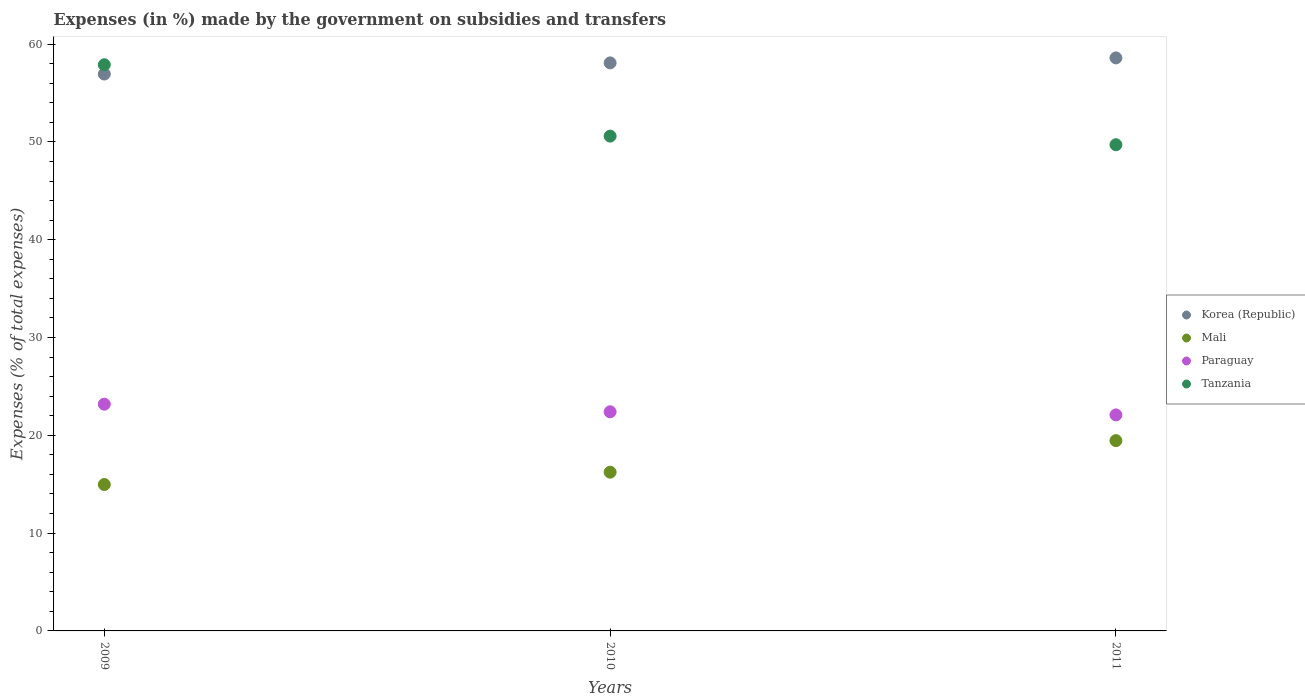How many different coloured dotlines are there?
Ensure brevity in your answer.  4. What is the percentage of expenses made by the government on subsidies and transfers in Tanzania in 2011?
Offer a very short reply. 49.71. Across all years, what is the maximum percentage of expenses made by the government on subsidies and transfers in Mali?
Your response must be concise. 19.46. Across all years, what is the minimum percentage of expenses made by the government on subsidies and transfers in Korea (Republic)?
Provide a succinct answer. 56.94. In which year was the percentage of expenses made by the government on subsidies and transfers in Tanzania maximum?
Your answer should be very brief. 2009. What is the total percentage of expenses made by the government on subsidies and transfers in Mali in the graph?
Offer a very short reply. 50.65. What is the difference between the percentage of expenses made by the government on subsidies and transfers in Paraguay in 2009 and that in 2010?
Make the answer very short. 0.78. What is the difference between the percentage of expenses made by the government on subsidies and transfers in Paraguay in 2011 and the percentage of expenses made by the government on subsidies and transfers in Korea (Republic) in 2009?
Your response must be concise. -34.85. What is the average percentage of expenses made by the government on subsidies and transfers in Korea (Republic) per year?
Your response must be concise. 57.87. In the year 2010, what is the difference between the percentage of expenses made by the government on subsidies and transfers in Paraguay and percentage of expenses made by the government on subsidies and transfers in Tanzania?
Provide a succinct answer. -28.19. What is the ratio of the percentage of expenses made by the government on subsidies and transfers in Paraguay in 2010 to that in 2011?
Keep it short and to the point. 1.01. Is the percentage of expenses made by the government on subsidies and transfers in Paraguay in 2009 less than that in 2010?
Make the answer very short. No. What is the difference between the highest and the second highest percentage of expenses made by the government on subsidies and transfers in Tanzania?
Make the answer very short. 7.3. What is the difference between the highest and the lowest percentage of expenses made by the government on subsidies and transfers in Korea (Republic)?
Give a very brief answer. 1.65. Does the percentage of expenses made by the government on subsidies and transfers in Mali monotonically increase over the years?
Offer a very short reply. Yes. Is the percentage of expenses made by the government on subsidies and transfers in Mali strictly less than the percentage of expenses made by the government on subsidies and transfers in Paraguay over the years?
Give a very brief answer. Yes. How many years are there in the graph?
Keep it short and to the point. 3. What is the difference between two consecutive major ticks on the Y-axis?
Make the answer very short. 10. Are the values on the major ticks of Y-axis written in scientific E-notation?
Your answer should be compact. No. How many legend labels are there?
Provide a succinct answer. 4. What is the title of the graph?
Ensure brevity in your answer.  Expenses (in %) made by the government on subsidies and transfers. What is the label or title of the Y-axis?
Provide a short and direct response. Expenses (% of total expenses). What is the Expenses (% of total expenses) in Korea (Republic) in 2009?
Provide a succinct answer. 56.94. What is the Expenses (% of total expenses) in Mali in 2009?
Your answer should be compact. 14.97. What is the Expenses (% of total expenses) of Paraguay in 2009?
Keep it short and to the point. 23.18. What is the Expenses (% of total expenses) of Tanzania in 2009?
Your answer should be compact. 57.89. What is the Expenses (% of total expenses) in Korea (Republic) in 2010?
Give a very brief answer. 58.08. What is the Expenses (% of total expenses) in Mali in 2010?
Your response must be concise. 16.23. What is the Expenses (% of total expenses) of Paraguay in 2010?
Make the answer very short. 22.4. What is the Expenses (% of total expenses) in Tanzania in 2010?
Your answer should be very brief. 50.59. What is the Expenses (% of total expenses) in Korea (Republic) in 2011?
Your answer should be very brief. 58.59. What is the Expenses (% of total expenses) of Mali in 2011?
Offer a very short reply. 19.46. What is the Expenses (% of total expenses) in Paraguay in 2011?
Your answer should be very brief. 22.09. What is the Expenses (% of total expenses) in Tanzania in 2011?
Provide a succinct answer. 49.71. Across all years, what is the maximum Expenses (% of total expenses) in Korea (Republic)?
Give a very brief answer. 58.59. Across all years, what is the maximum Expenses (% of total expenses) in Mali?
Your answer should be very brief. 19.46. Across all years, what is the maximum Expenses (% of total expenses) of Paraguay?
Provide a succinct answer. 23.18. Across all years, what is the maximum Expenses (% of total expenses) in Tanzania?
Offer a very short reply. 57.89. Across all years, what is the minimum Expenses (% of total expenses) in Korea (Republic)?
Make the answer very short. 56.94. Across all years, what is the minimum Expenses (% of total expenses) of Mali?
Offer a terse response. 14.97. Across all years, what is the minimum Expenses (% of total expenses) in Paraguay?
Offer a very short reply. 22.09. Across all years, what is the minimum Expenses (% of total expenses) of Tanzania?
Provide a short and direct response. 49.71. What is the total Expenses (% of total expenses) of Korea (Republic) in the graph?
Make the answer very short. 173.6. What is the total Expenses (% of total expenses) in Mali in the graph?
Make the answer very short. 50.65. What is the total Expenses (% of total expenses) of Paraguay in the graph?
Give a very brief answer. 67.67. What is the total Expenses (% of total expenses) in Tanzania in the graph?
Give a very brief answer. 158.19. What is the difference between the Expenses (% of total expenses) of Korea (Republic) in 2009 and that in 2010?
Provide a succinct answer. -1.14. What is the difference between the Expenses (% of total expenses) in Mali in 2009 and that in 2010?
Keep it short and to the point. -1.26. What is the difference between the Expenses (% of total expenses) in Paraguay in 2009 and that in 2010?
Make the answer very short. 0.78. What is the difference between the Expenses (% of total expenses) in Tanzania in 2009 and that in 2010?
Provide a succinct answer. 7.3. What is the difference between the Expenses (% of total expenses) of Korea (Republic) in 2009 and that in 2011?
Your answer should be very brief. -1.65. What is the difference between the Expenses (% of total expenses) in Mali in 2009 and that in 2011?
Make the answer very short. -4.49. What is the difference between the Expenses (% of total expenses) of Paraguay in 2009 and that in 2011?
Provide a succinct answer. 1.1. What is the difference between the Expenses (% of total expenses) of Tanzania in 2009 and that in 2011?
Offer a terse response. 8.18. What is the difference between the Expenses (% of total expenses) of Korea (Republic) in 2010 and that in 2011?
Your answer should be very brief. -0.51. What is the difference between the Expenses (% of total expenses) in Mali in 2010 and that in 2011?
Provide a succinct answer. -3.23. What is the difference between the Expenses (% of total expenses) of Paraguay in 2010 and that in 2011?
Ensure brevity in your answer.  0.32. What is the difference between the Expenses (% of total expenses) in Tanzania in 2010 and that in 2011?
Keep it short and to the point. 0.88. What is the difference between the Expenses (% of total expenses) in Korea (Republic) in 2009 and the Expenses (% of total expenses) in Mali in 2010?
Offer a very short reply. 40.71. What is the difference between the Expenses (% of total expenses) in Korea (Republic) in 2009 and the Expenses (% of total expenses) in Paraguay in 2010?
Offer a terse response. 34.53. What is the difference between the Expenses (% of total expenses) in Korea (Republic) in 2009 and the Expenses (% of total expenses) in Tanzania in 2010?
Offer a very short reply. 6.35. What is the difference between the Expenses (% of total expenses) in Mali in 2009 and the Expenses (% of total expenses) in Paraguay in 2010?
Ensure brevity in your answer.  -7.44. What is the difference between the Expenses (% of total expenses) in Mali in 2009 and the Expenses (% of total expenses) in Tanzania in 2010?
Give a very brief answer. -35.62. What is the difference between the Expenses (% of total expenses) of Paraguay in 2009 and the Expenses (% of total expenses) of Tanzania in 2010?
Offer a very short reply. -27.41. What is the difference between the Expenses (% of total expenses) in Korea (Republic) in 2009 and the Expenses (% of total expenses) in Mali in 2011?
Ensure brevity in your answer.  37.48. What is the difference between the Expenses (% of total expenses) of Korea (Republic) in 2009 and the Expenses (% of total expenses) of Paraguay in 2011?
Your answer should be very brief. 34.85. What is the difference between the Expenses (% of total expenses) of Korea (Republic) in 2009 and the Expenses (% of total expenses) of Tanzania in 2011?
Provide a succinct answer. 7.23. What is the difference between the Expenses (% of total expenses) of Mali in 2009 and the Expenses (% of total expenses) of Paraguay in 2011?
Offer a terse response. -7.12. What is the difference between the Expenses (% of total expenses) of Mali in 2009 and the Expenses (% of total expenses) of Tanzania in 2011?
Your response must be concise. -34.74. What is the difference between the Expenses (% of total expenses) in Paraguay in 2009 and the Expenses (% of total expenses) in Tanzania in 2011?
Your response must be concise. -26.53. What is the difference between the Expenses (% of total expenses) in Korea (Republic) in 2010 and the Expenses (% of total expenses) in Mali in 2011?
Offer a very short reply. 38.62. What is the difference between the Expenses (% of total expenses) of Korea (Republic) in 2010 and the Expenses (% of total expenses) of Paraguay in 2011?
Your answer should be very brief. 35.99. What is the difference between the Expenses (% of total expenses) of Korea (Republic) in 2010 and the Expenses (% of total expenses) of Tanzania in 2011?
Offer a very short reply. 8.37. What is the difference between the Expenses (% of total expenses) in Mali in 2010 and the Expenses (% of total expenses) in Paraguay in 2011?
Make the answer very short. -5.86. What is the difference between the Expenses (% of total expenses) of Mali in 2010 and the Expenses (% of total expenses) of Tanzania in 2011?
Offer a terse response. -33.48. What is the difference between the Expenses (% of total expenses) in Paraguay in 2010 and the Expenses (% of total expenses) in Tanzania in 2011?
Keep it short and to the point. -27.31. What is the average Expenses (% of total expenses) in Korea (Republic) per year?
Make the answer very short. 57.87. What is the average Expenses (% of total expenses) in Mali per year?
Make the answer very short. 16.88. What is the average Expenses (% of total expenses) of Paraguay per year?
Ensure brevity in your answer.  22.56. What is the average Expenses (% of total expenses) of Tanzania per year?
Make the answer very short. 52.73. In the year 2009, what is the difference between the Expenses (% of total expenses) in Korea (Republic) and Expenses (% of total expenses) in Mali?
Keep it short and to the point. 41.97. In the year 2009, what is the difference between the Expenses (% of total expenses) in Korea (Republic) and Expenses (% of total expenses) in Paraguay?
Offer a terse response. 33.76. In the year 2009, what is the difference between the Expenses (% of total expenses) in Korea (Republic) and Expenses (% of total expenses) in Tanzania?
Keep it short and to the point. -0.95. In the year 2009, what is the difference between the Expenses (% of total expenses) in Mali and Expenses (% of total expenses) in Paraguay?
Your answer should be compact. -8.21. In the year 2009, what is the difference between the Expenses (% of total expenses) of Mali and Expenses (% of total expenses) of Tanzania?
Offer a very short reply. -42.92. In the year 2009, what is the difference between the Expenses (% of total expenses) of Paraguay and Expenses (% of total expenses) of Tanzania?
Keep it short and to the point. -34.71. In the year 2010, what is the difference between the Expenses (% of total expenses) of Korea (Republic) and Expenses (% of total expenses) of Mali?
Your answer should be compact. 41.85. In the year 2010, what is the difference between the Expenses (% of total expenses) of Korea (Republic) and Expenses (% of total expenses) of Paraguay?
Provide a short and direct response. 35.67. In the year 2010, what is the difference between the Expenses (% of total expenses) in Korea (Republic) and Expenses (% of total expenses) in Tanzania?
Make the answer very short. 7.49. In the year 2010, what is the difference between the Expenses (% of total expenses) of Mali and Expenses (% of total expenses) of Paraguay?
Provide a short and direct response. -6.18. In the year 2010, what is the difference between the Expenses (% of total expenses) of Mali and Expenses (% of total expenses) of Tanzania?
Offer a very short reply. -34.36. In the year 2010, what is the difference between the Expenses (% of total expenses) in Paraguay and Expenses (% of total expenses) in Tanzania?
Give a very brief answer. -28.19. In the year 2011, what is the difference between the Expenses (% of total expenses) in Korea (Republic) and Expenses (% of total expenses) in Mali?
Your answer should be very brief. 39.13. In the year 2011, what is the difference between the Expenses (% of total expenses) in Korea (Republic) and Expenses (% of total expenses) in Paraguay?
Give a very brief answer. 36.5. In the year 2011, what is the difference between the Expenses (% of total expenses) of Korea (Republic) and Expenses (% of total expenses) of Tanzania?
Ensure brevity in your answer.  8.88. In the year 2011, what is the difference between the Expenses (% of total expenses) of Mali and Expenses (% of total expenses) of Paraguay?
Your response must be concise. -2.63. In the year 2011, what is the difference between the Expenses (% of total expenses) in Mali and Expenses (% of total expenses) in Tanzania?
Ensure brevity in your answer.  -30.25. In the year 2011, what is the difference between the Expenses (% of total expenses) of Paraguay and Expenses (% of total expenses) of Tanzania?
Make the answer very short. -27.62. What is the ratio of the Expenses (% of total expenses) of Korea (Republic) in 2009 to that in 2010?
Give a very brief answer. 0.98. What is the ratio of the Expenses (% of total expenses) of Mali in 2009 to that in 2010?
Keep it short and to the point. 0.92. What is the ratio of the Expenses (% of total expenses) of Paraguay in 2009 to that in 2010?
Offer a terse response. 1.03. What is the ratio of the Expenses (% of total expenses) in Tanzania in 2009 to that in 2010?
Ensure brevity in your answer.  1.14. What is the ratio of the Expenses (% of total expenses) in Korea (Republic) in 2009 to that in 2011?
Your answer should be very brief. 0.97. What is the ratio of the Expenses (% of total expenses) of Mali in 2009 to that in 2011?
Provide a short and direct response. 0.77. What is the ratio of the Expenses (% of total expenses) of Paraguay in 2009 to that in 2011?
Provide a short and direct response. 1.05. What is the ratio of the Expenses (% of total expenses) of Tanzania in 2009 to that in 2011?
Make the answer very short. 1.16. What is the ratio of the Expenses (% of total expenses) in Mali in 2010 to that in 2011?
Your answer should be compact. 0.83. What is the ratio of the Expenses (% of total expenses) of Paraguay in 2010 to that in 2011?
Offer a terse response. 1.01. What is the ratio of the Expenses (% of total expenses) of Tanzania in 2010 to that in 2011?
Your answer should be compact. 1.02. What is the difference between the highest and the second highest Expenses (% of total expenses) in Korea (Republic)?
Give a very brief answer. 0.51. What is the difference between the highest and the second highest Expenses (% of total expenses) of Mali?
Provide a short and direct response. 3.23. What is the difference between the highest and the second highest Expenses (% of total expenses) of Paraguay?
Your answer should be compact. 0.78. What is the difference between the highest and the second highest Expenses (% of total expenses) of Tanzania?
Your answer should be very brief. 7.3. What is the difference between the highest and the lowest Expenses (% of total expenses) in Korea (Republic)?
Offer a terse response. 1.65. What is the difference between the highest and the lowest Expenses (% of total expenses) of Mali?
Offer a very short reply. 4.49. What is the difference between the highest and the lowest Expenses (% of total expenses) of Paraguay?
Provide a succinct answer. 1.1. What is the difference between the highest and the lowest Expenses (% of total expenses) in Tanzania?
Your response must be concise. 8.18. 